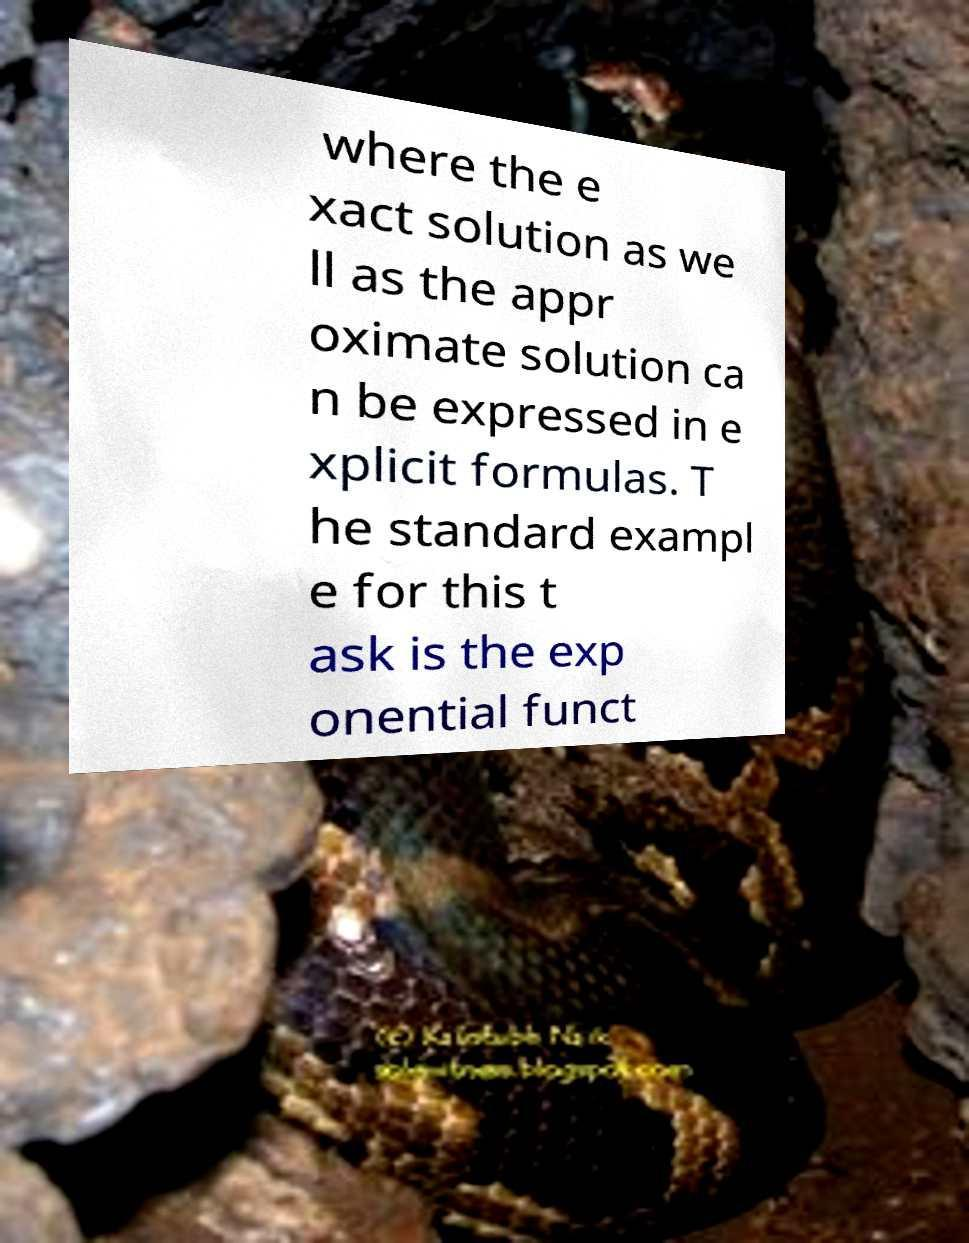Could you assist in decoding the text presented in this image and type it out clearly? where the e xact solution as we ll as the appr oximate solution ca n be expressed in e xplicit formulas. T he standard exampl e for this t ask is the exp onential funct 